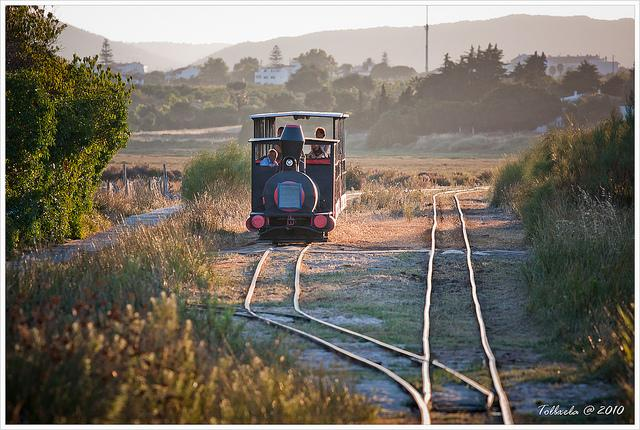How far will this train travel usually? not far 